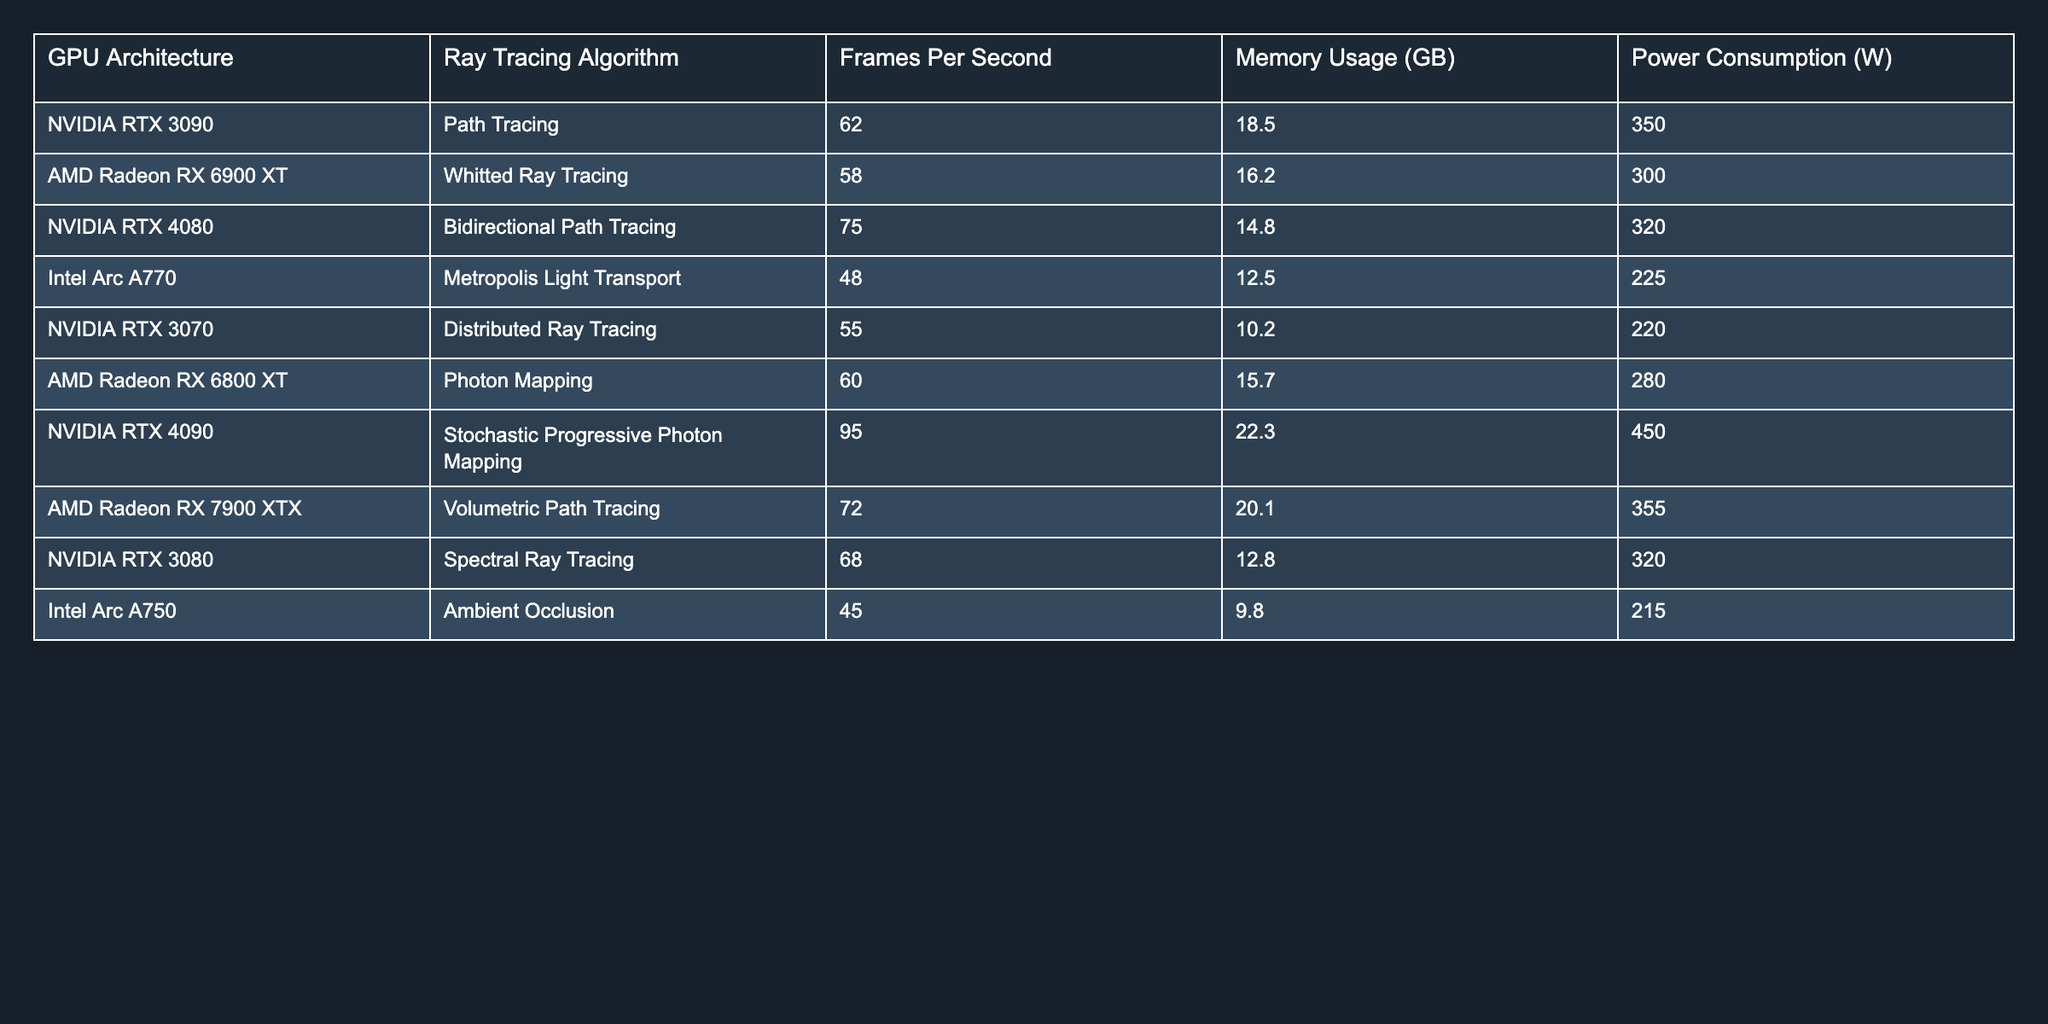What is the frames per second (FPS) for the NVIDIA RTX 4090 running Stochastic Progressive Photon Mapping? The table indicates that the frames per second for the NVIDIA RTX 4090 running Stochastic Progressive Photon Mapping is 95.
Answer: 95 Which ray tracing algorithm uses the least memory? By reviewing the memory usage column, the Intel Arc A750 using Ambient Occlusion has the lowest memory usage at 9.8 GB.
Answer: 9.8 GB What is the average power consumption of all listed GPUs? To find the average, we sum the power consumption values: (350 + 300 + 320 + 225 + 220 + 280 + 450 + 355 + 320 + 215) = 2790, then divide by the number of GPUs (10), which gives us 2790 / 10 = 279.
Answer: 279 W Is the AMD Radeon RX 6800 XT more power-efficient than the NVIDIA RTX 3070? The AMD Radeon RX 6800 XT has a power consumption of 280 W while the NVIDIA RTX 3070 consumes 220 W. Therefore, the NVIDIA RTX 3070 is more power-efficient.
Answer: No What is the difference in frames per second between the NVIDIA RTX 4080 and the AMD Radeon RX 6900 XT? The NVIDIA RTX 4080 achieves 75 FPS while the AMD Radeon RX 6900 XT reaches 58 FPS. The difference is 75 - 58 = 17 FPS.
Answer: 17 FPS Which GPU architecture has the highest memory usage, and how much is it? From the memory usage column, the NVIDIA RTX 4090 has the highest memory usage at 22.3 GB.
Answer: 22.3 GB How many GPUs exceed 60 frames per second? By checking the FPS column, the following GPUs exceed 60 FPS: NVIDIA RTX 4090 (95), NVIDIA RTX 4080 (75), AMD Radeon RX 7900 XTX (72), and NVIDIA RTX 3090 (62). This counts as 4 GPUs.
Answer: 4 What is the total memory usage of all GPUs listed? Adding all memory usage values: (18.5 + 16.2 + 14.8 + 12.5 + 10.2 + 15.7 + 22.3 + 20.1 + 12.8 + 9.8) =  139.1 GB.
Answer: 139.1 GB Does the Intel Arc A770 consume more power than the AMD Radeon RX 6800 XT? The Intel Arc A770 uses 225 W, while the AMD Radeon RX 6800 XT consumes 280 W, so the Intel Arc A770 consumes less power.
Answer: No What is the median FPS of the listed ray tracing algorithms? To find the median, we arrange the FPS values in ascending order: 45, 48, 55, 58, 60, 62, 68, 72, 75, 95. The middle values are 60 and 62, and their average is (60 + 62) / 2 = 61.
Answer: 61 FPS 